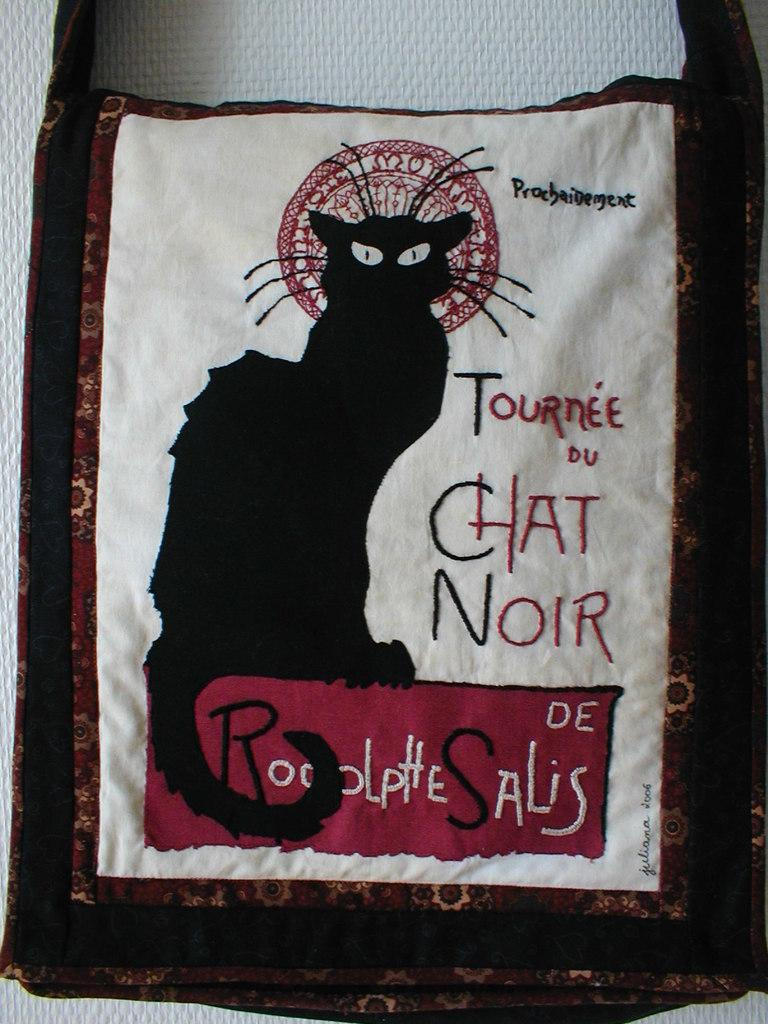What object is present in the image that can be used for carrying items? There is a bag in the image that can be used for carrying items. Where is the bag located in the image? The bag is on a white surface in the image. What is on top of the bag in the image? There is a cat on the bag in the image. What can be seen on the bag besides the cat? There is text on the bag in the image. Can you see any eggs in the image? No, there are no eggs present in the image. Is there a harbor visible in the image? No, there is no harbor visible in the image. 